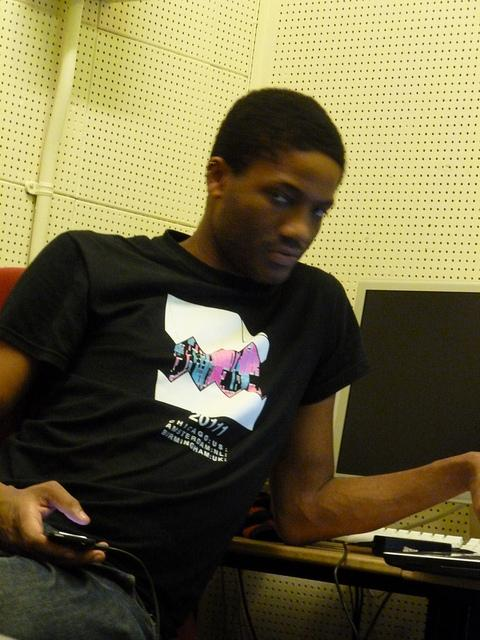What is the purpose of the holes behind him? pegboard 